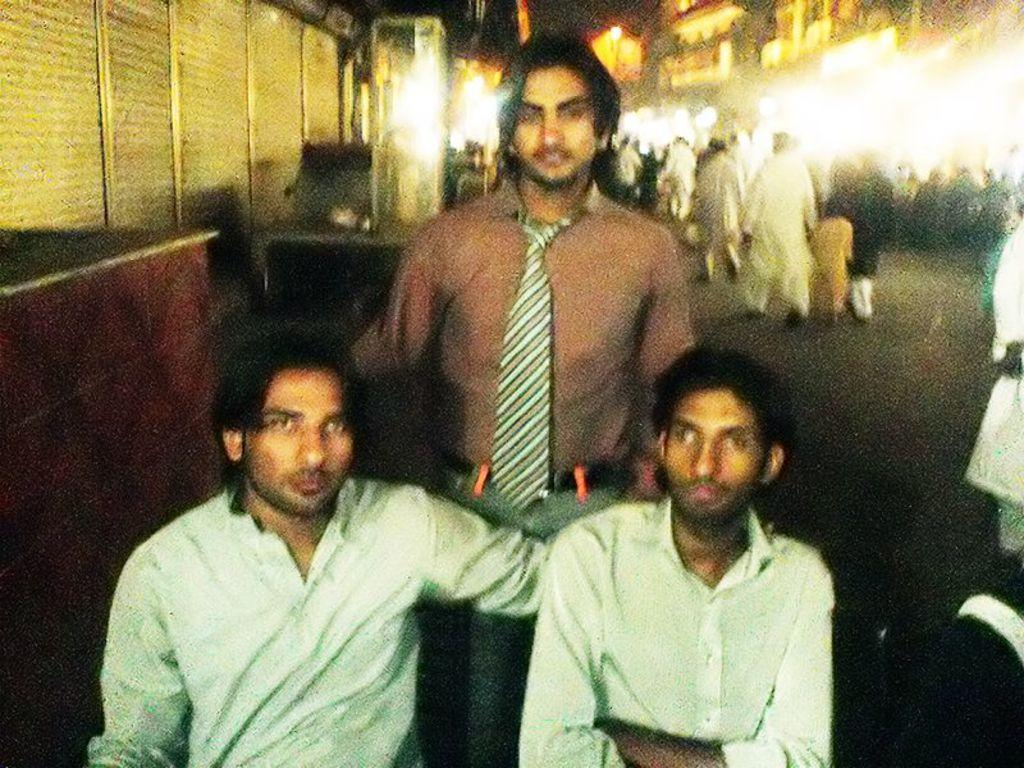What is the dominant color in the image? The image has a blue color. How many people are in the image? There are three people in the image. Can you describe the person in the middle? The person in the middle is standing and wearing a tie. What can be seen in the background of the image? There is a wall, people, buildings, and a road in the background of the image. What language are the sheep speaking in the image? There are no sheep present in the image, so it is not possible to determine what language they might be speaking. 